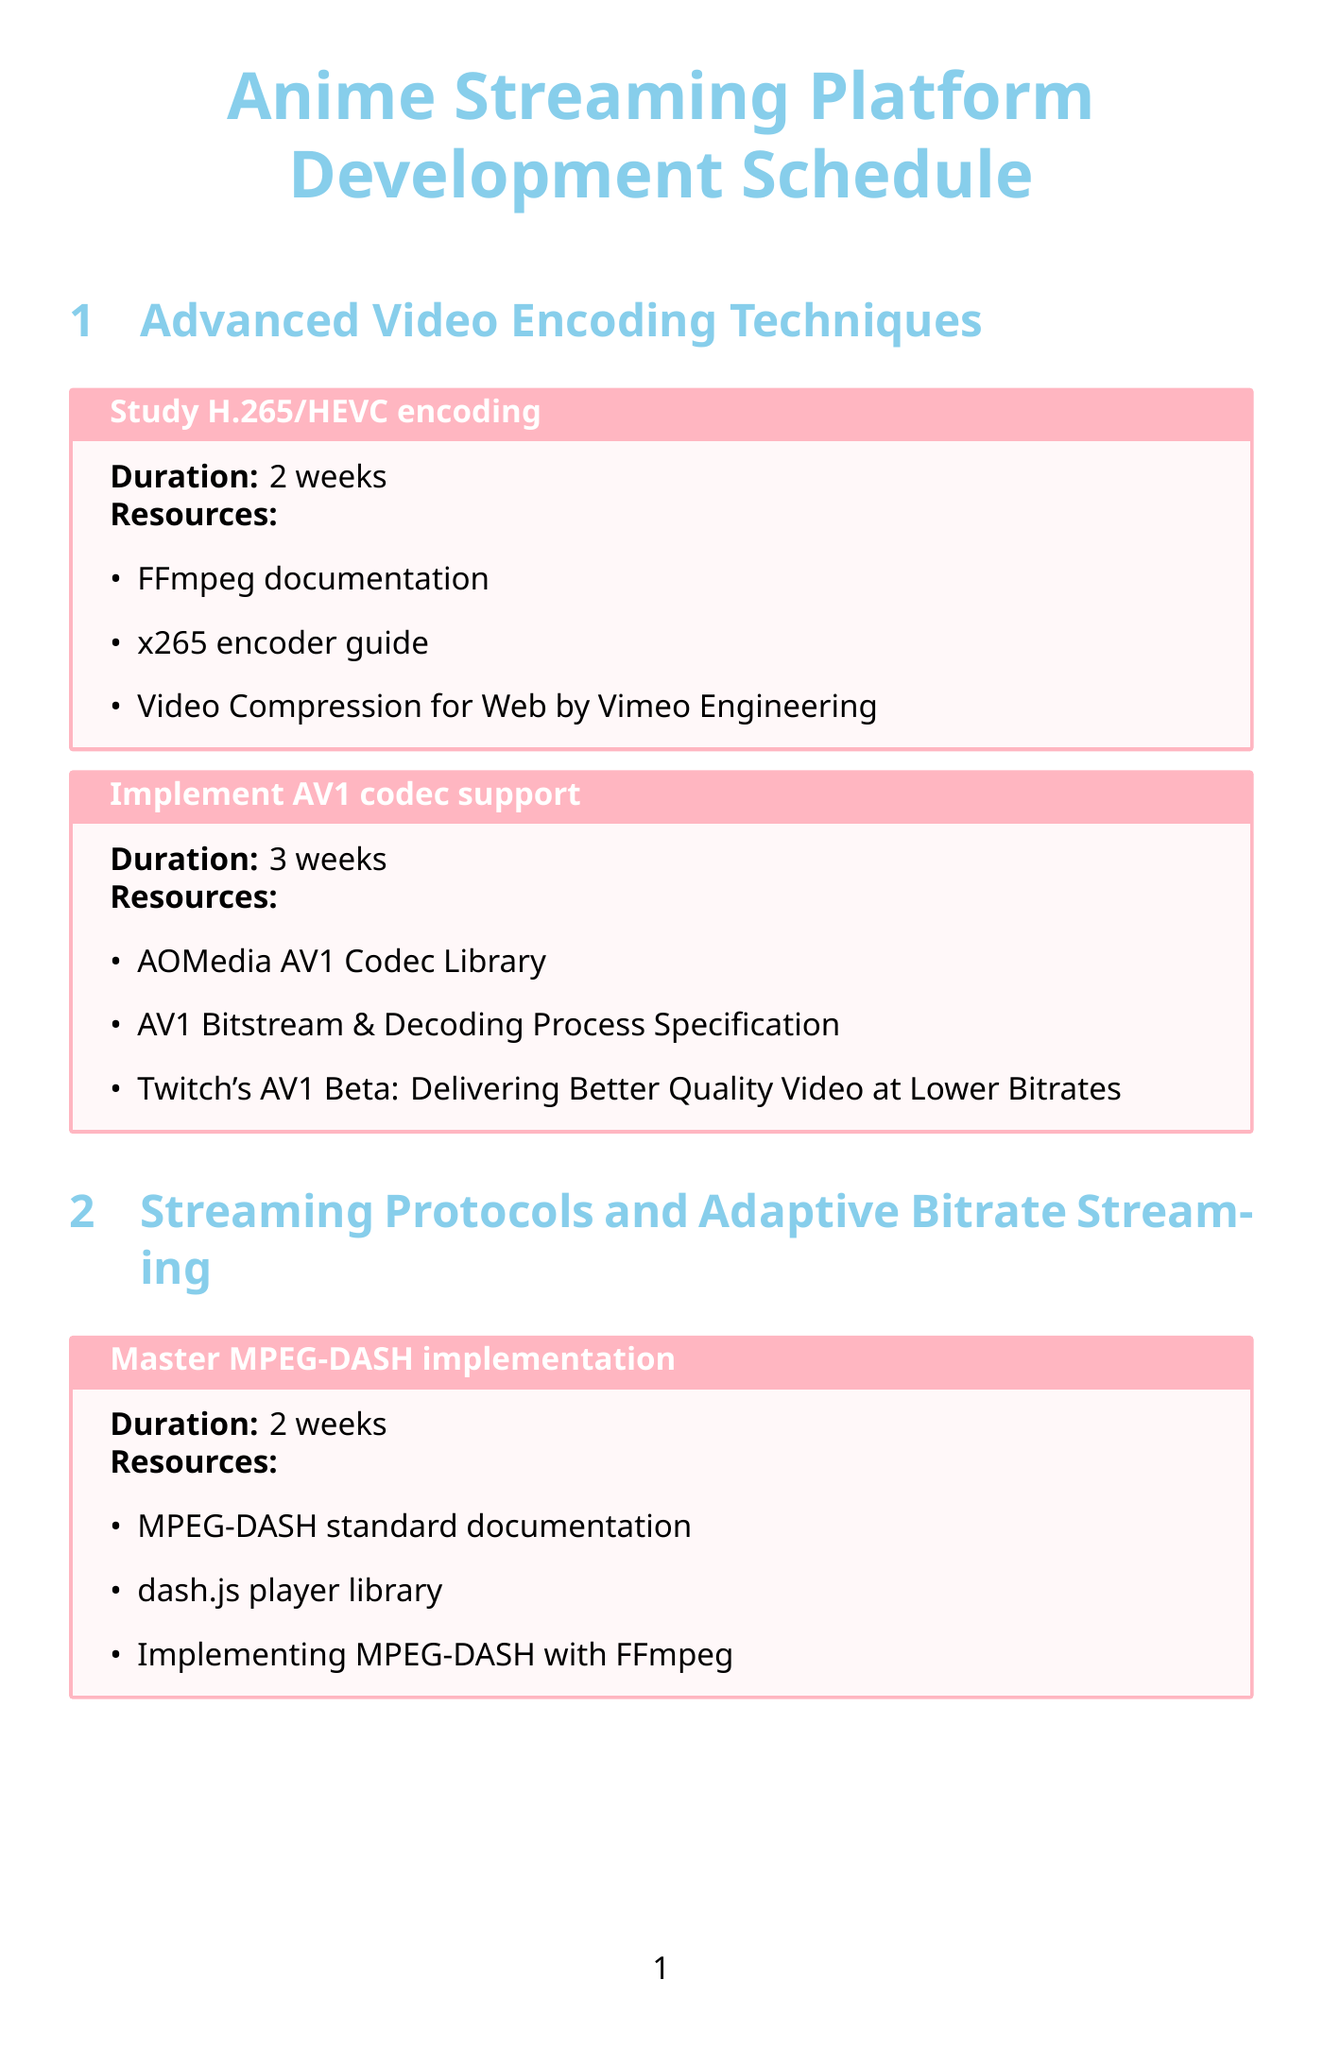What is the duration for implementing AV1 codec support? The duration for implementing AV1 codec support is specified in the document under the 'Advanced Video Encoding Techniques' section.
Answer: 3 weeks How many weeks are allocated for optimizing HLS delivery? The document lists the allocated duration for optimizing HLS delivery, which can be found in the 'Streaming Protocols and Adaptive Bitrate Streaming' section.
Answer: 2 weeks What resource is listed for customizing the Shaka Player? The document provides a list of resources for customizing the Shaka Player, specifically under the 'Video Player Development' section.
Answer: Shaka Player documentation What is the main focus of the 'User Experience and Anime-Specific Features' section? The main focus of this section is to improve user engagement and interaction within the anime streaming platform, based on the document's activities.
Answer: Recommendation engine and real-time chat system How many activities are included in the 'Content Delivery Network (CDN) Integration' section? The document provides a detailed list of activities in the 'Content Delivery Network (CDN) Integration' section.
Answer: 2 activities What is the total duration for Backend Scalability and Performance activities? The total duration can be calculated by adding the durations of both activities in the 'Backend Scalability and Performance' section.
Answer: 6 weeks Which library is recommended for implementing server-side ad insertion? The document specifies a library for server-side ad insertion in the 'Content Delivery Network (CDN) Integration' section.
Answer: AWS MediaTailor What topic does the activity involving collaborative filtering algorithms pertain to? This topic is discussed in the context of developing a recommendation engine, as detailed in the 'User Experience and Anime-Specific Features' section.
Answer: Recommendation engine 